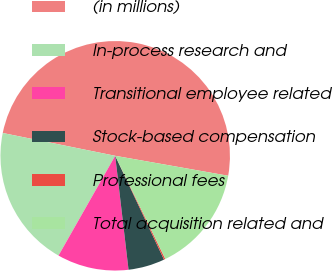Convert chart to OTSL. <chart><loc_0><loc_0><loc_500><loc_500><pie_chart><fcel>(in millions)<fcel>In-process research and<fcel>Transitional employee related<fcel>Stock-based compensation<fcel>Professional fees<fcel>Total acquisition related and<nl><fcel>49.6%<fcel>19.96%<fcel>10.08%<fcel>5.14%<fcel>0.2%<fcel>15.02%<nl></chart> 